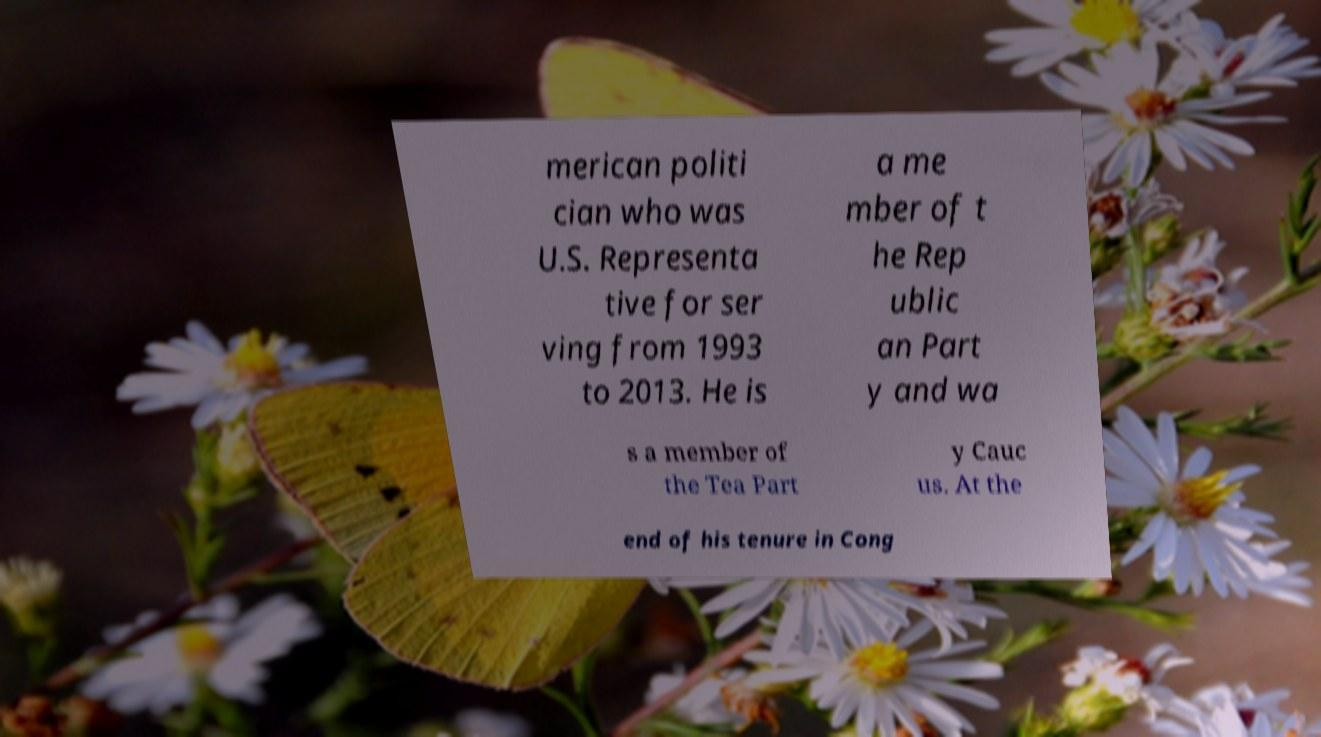Please read and relay the text visible in this image. What does it say? merican politi cian who was U.S. Representa tive for ser ving from 1993 to 2013. He is a me mber of t he Rep ublic an Part y and wa s a member of the Tea Part y Cauc us. At the end of his tenure in Cong 